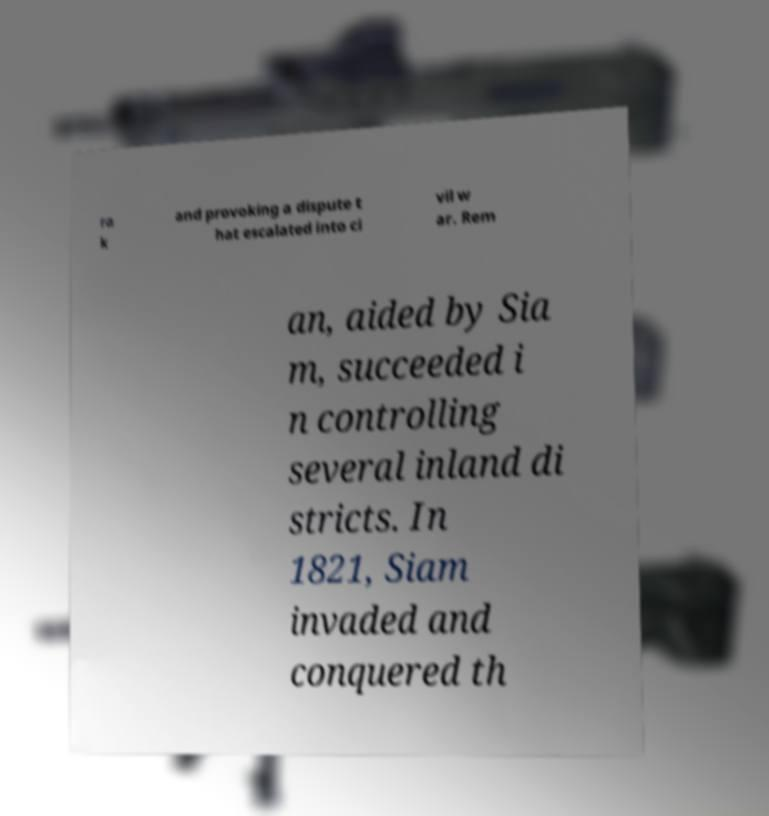Could you assist in decoding the text presented in this image and type it out clearly? ra k and provoking a dispute t hat escalated into ci vil w ar. Rem an, aided by Sia m, succeeded i n controlling several inland di stricts. In 1821, Siam invaded and conquered th 